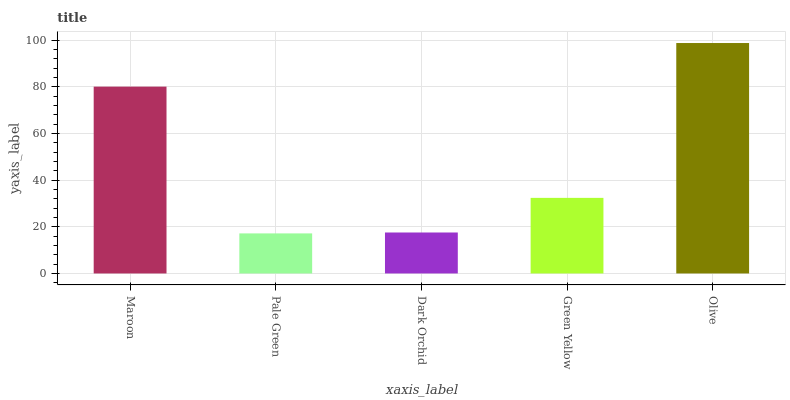Is Pale Green the minimum?
Answer yes or no. Yes. Is Olive the maximum?
Answer yes or no. Yes. Is Dark Orchid the minimum?
Answer yes or no. No. Is Dark Orchid the maximum?
Answer yes or no. No. Is Dark Orchid greater than Pale Green?
Answer yes or no. Yes. Is Pale Green less than Dark Orchid?
Answer yes or no. Yes. Is Pale Green greater than Dark Orchid?
Answer yes or no. No. Is Dark Orchid less than Pale Green?
Answer yes or no. No. Is Green Yellow the high median?
Answer yes or no. Yes. Is Green Yellow the low median?
Answer yes or no. Yes. Is Dark Orchid the high median?
Answer yes or no. No. Is Pale Green the low median?
Answer yes or no. No. 